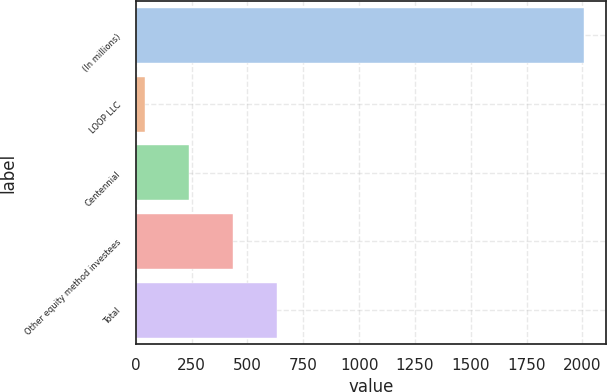<chart> <loc_0><loc_0><loc_500><loc_500><bar_chart><fcel>(In millions)<fcel>LOOP LLC<fcel>Centennial<fcel>Other equity method investees<fcel>Total<nl><fcel>2007<fcel>43<fcel>239.4<fcel>435.8<fcel>632.2<nl></chart> 